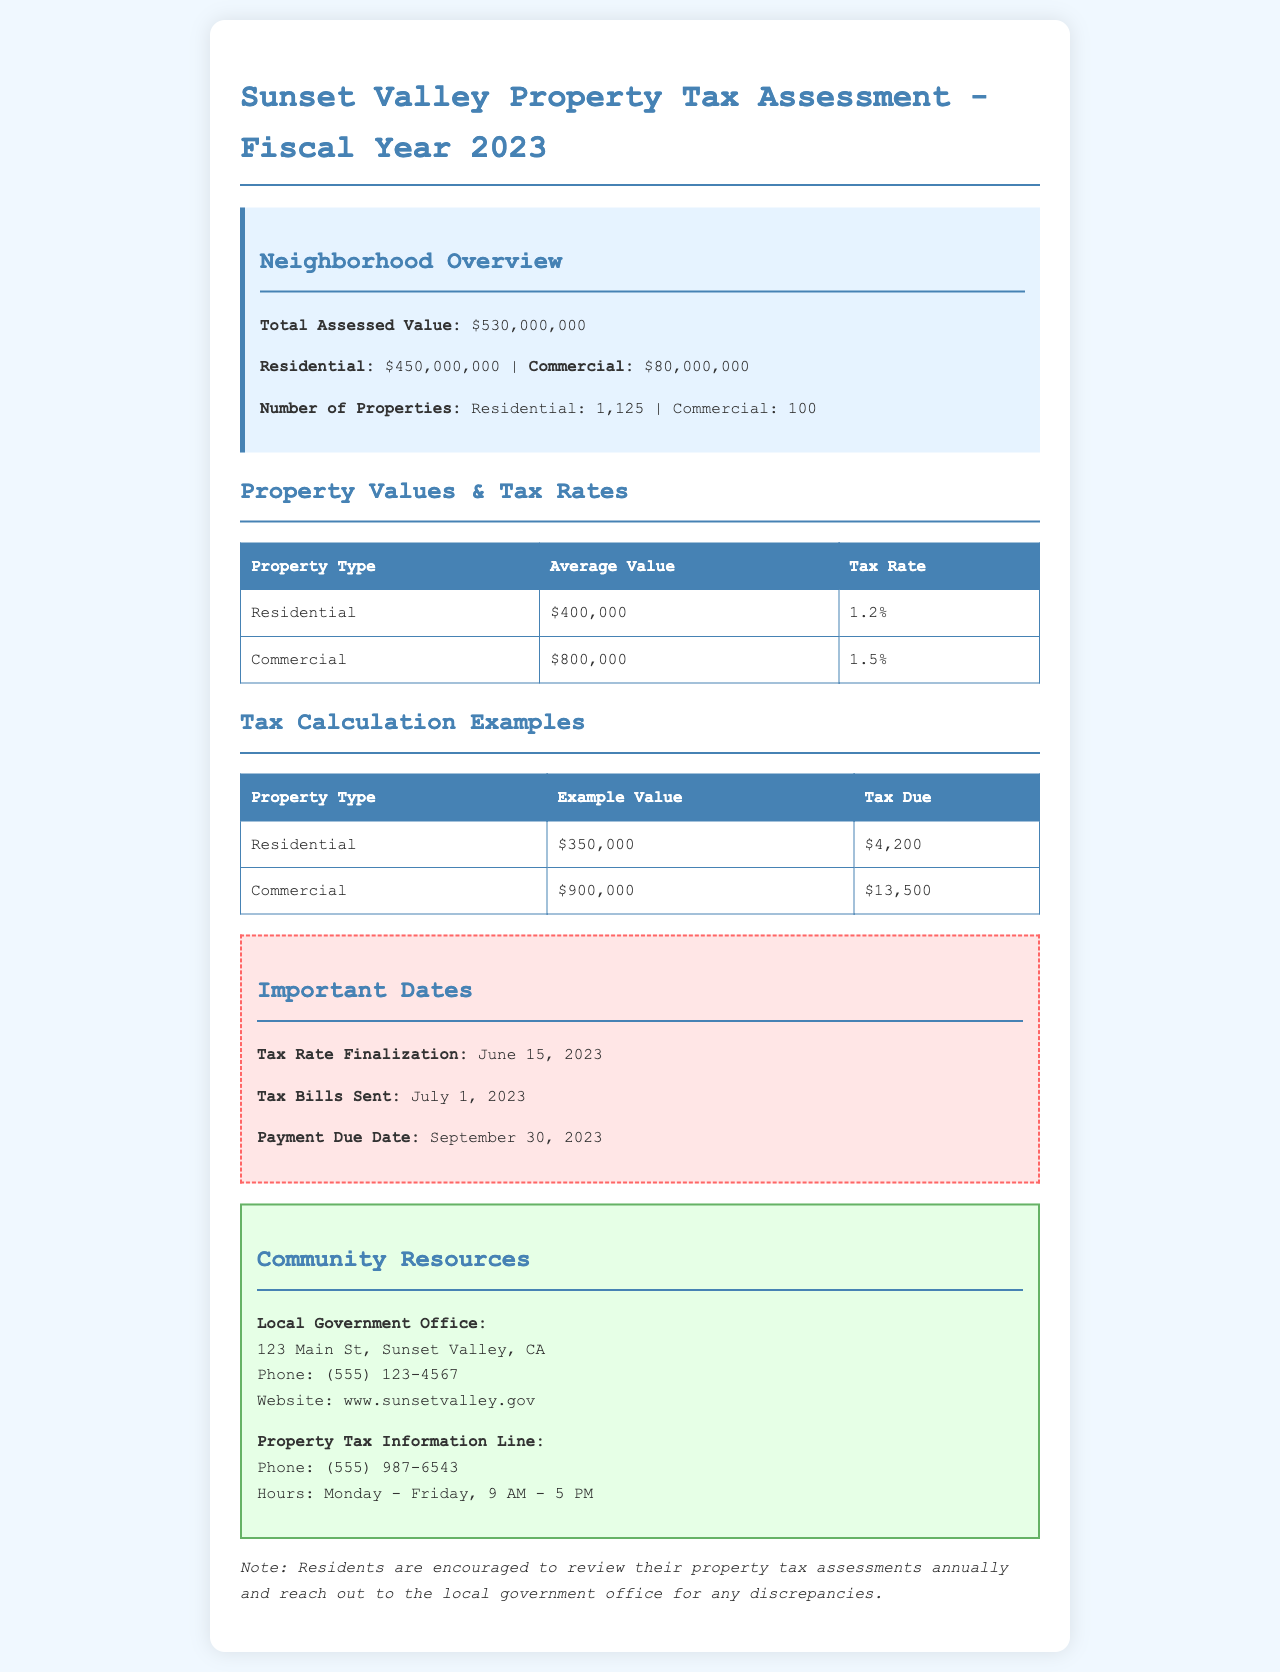What is the total assessed value? The total assessed value represents the combined value of residential and commercial properties in the neighborhood, which is $530,000,000.
Answer: $530,000,000 What is the average value of residential properties? The average value of residential properties is specifically listed in the document as $400,000.
Answer: $400,000 What is the tax rate for commercial properties? The tax rate for commercial properties is mentioned as 1.5%.
Answer: 1.5% What is the payment due date for property taxes? The payment due date is given as September 30, 2023.
Answer: September 30, 2023 How much tax is due on a residential property valued at $350,000? The tax due is calculated based on the example value provided, which shows $4,200 due for a residential property valued at $350,000.
Answer: $4,200 What are the important dates related to property tax in 2023? The important dates include tax rate finalization on June 15, tax bills sent on July 1, and payment due date on September 30.
Answer: June 15, July 1, September 30 What is the total value of commercial properties? The total value of commercial properties is shown in the document as $80,000,000.
Answer: $80,000,000 How many residential properties are in the neighborhood? The document specifies that there are 1,125 residential properties in the neighborhood.
Answer: 1,125 Where is the local government office located? The document provides the address of the local government office as 123 Main St, Sunset Valley, CA.
Answer: 123 Main St, Sunset Valley, CA 